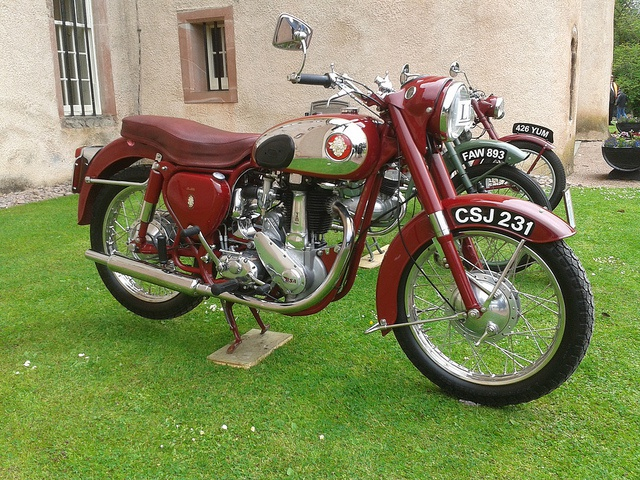Describe the objects in this image and their specific colors. I can see motorcycle in ivory, black, maroon, gray, and darkgray tones, motorcycle in ivory, black, gray, darkgray, and lightgray tones, potted plant in ivory, black, gray, darkgray, and darkgreen tones, people in ivory, black, gray, and darkgray tones, and people in ivory, black, gray, and blue tones in this image. 